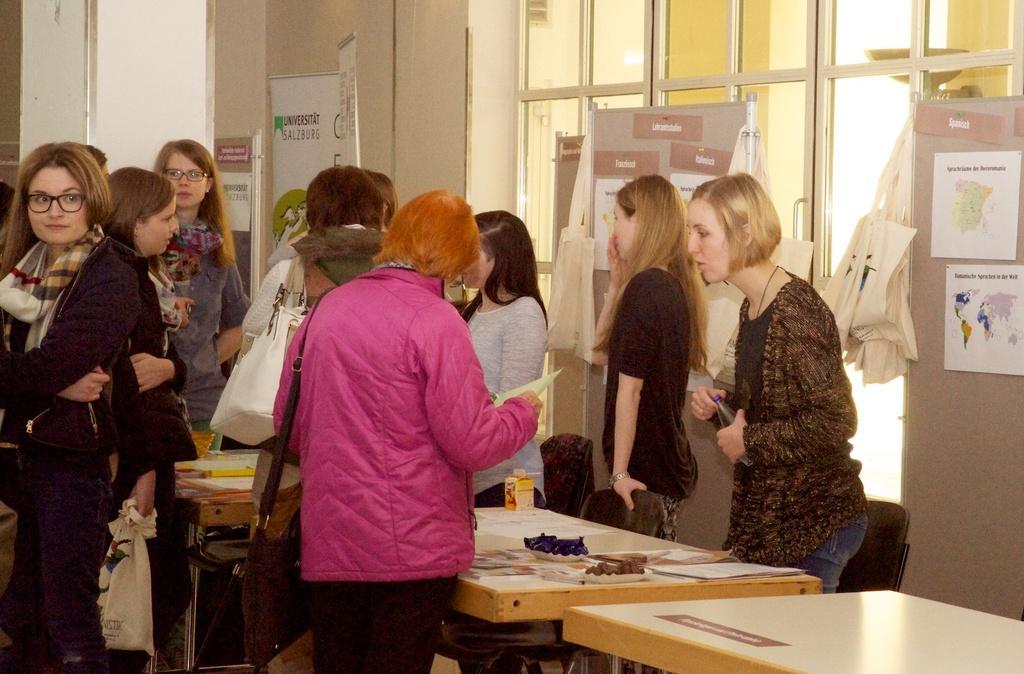Can you describe this image briefly? In this image i can see a group of people are standing in front of table. On the table we have few objects on it. 